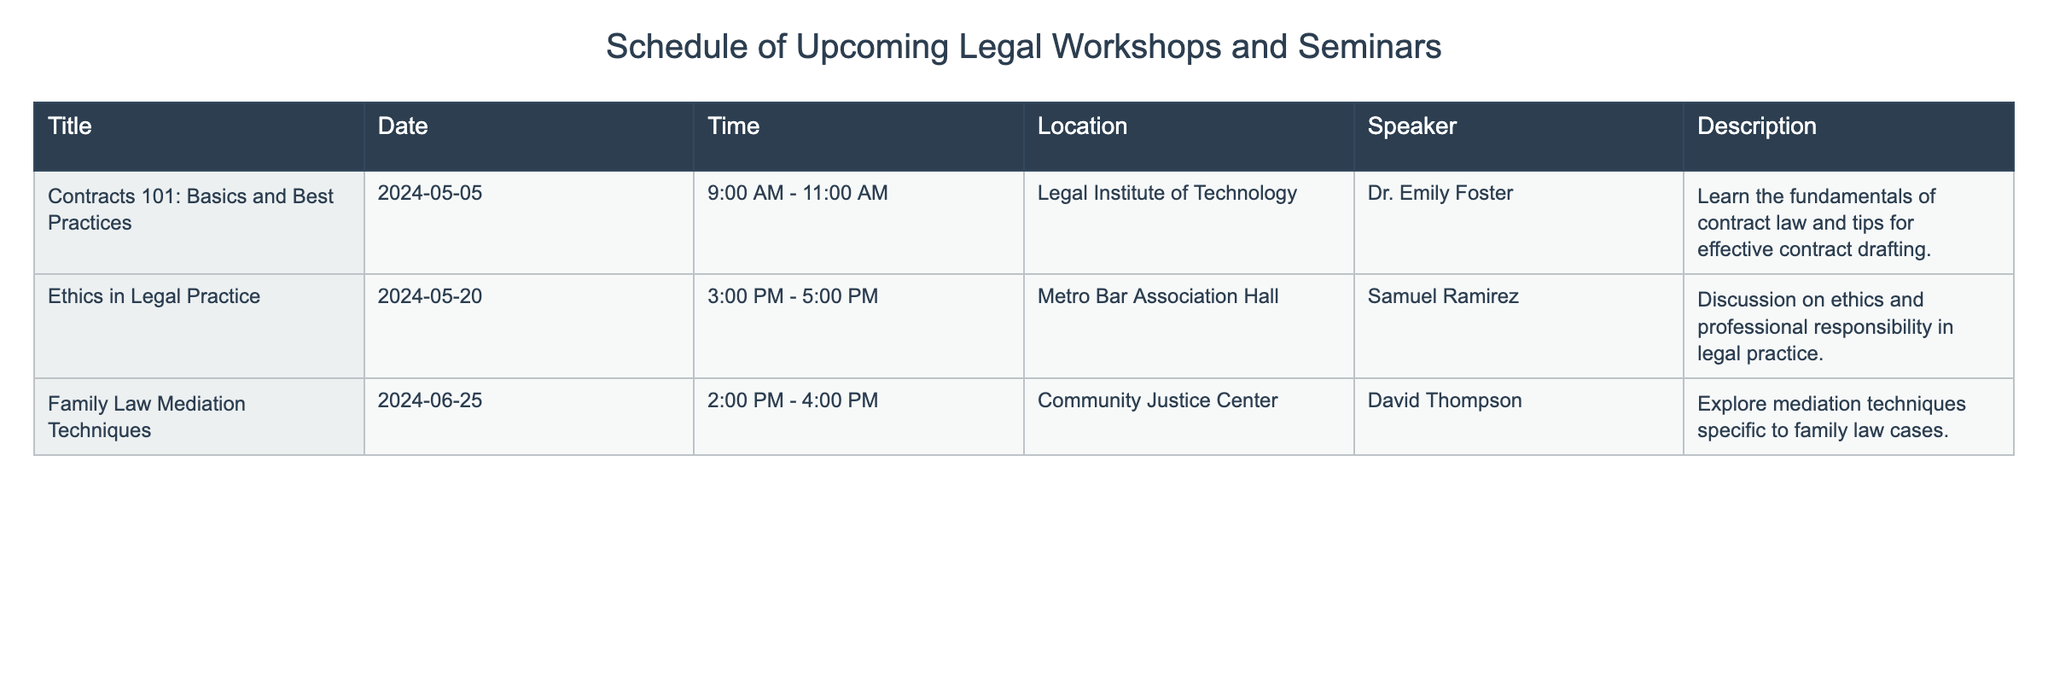What is the date of the "Contracts 101: Basics and Best Practices" workshop? The table lists the date for the "Contracts 101: Basics and Best Practices" workshop directly under the Date column. It shows "2024-05-05."
Answer: 2024-05-05 Who is the speaker for the "Ethics in Legal Practice" seminar? The table provides the name of the speaker for the "Ethics in Legal Practice" seminar under the Speaker column. The speaker listed is "Samuel Ramirez."
Answer: Samuel Ramirez What time does the "Family Law Mediation Techniques" seminar start? The table displays the starting time for the "Family Law Mediation Techniques" seminar in the Time column. It shows "2:00 PM."
Answer: 2:00 PM Is there a workshop scheduled on May 20, 2024? By examining the Date column in the table, we can see that there is a workshop listed on May 20, 2024, specifically the "Ethics in Legal Practice" seminar.
Answer: Yes What is the average time duration of the workshops listed in the table? To determine the average duration, first convert the time slots into durations: "Contracts 101" lasts 2 hours, "Ethics in Legal Practice" also lasts 2 hours, and "Family Law Mediation Techniques" lasts 2 hours as well. There are 3 workshops, so the average duration is (2 + 2 + 2) / 3 = 2 hours.
Answer: 2 hours Which workshop has the earliest time frame? The earliest start time is for "Contracts 101: Basics and Best Practices," starting at 9:00 AM. The other workshops start later, at 2:00 PM and 3:00 PM. This comparison establishes it as the earliest.
Answer: Contracts 101: Basics and Best Practices Are all workshops held at different locations? By checking the Location column, we see "Legal Institute of Technology," "Metro Bar Association Hall," and "Community Justice Center," indicating each workshop has a unique venue. Therefore, the answer is determined from this information.
Answer: Yes Who is the speaker for the workshop scheduled for June 25, 2024? The workshop on June 25, 2024, is "Family Law Mediation Techniques," and according to the Speaker column, the speaker is "David Thompson."
Answer: David Thompson Identify the workshop that focuses on ethics in legal practice. The description for the workshop named "Ethics in Legal Practice" directly addresses this focus, confirming that it certainly is centered on ethics and professional responsibility within the legal field.
Answer: Ethics in Legal Practice 